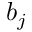Convert formula to latex. <formula><loc_0><loc_0><loc_500><loc_500>b _ { j }</formula> 